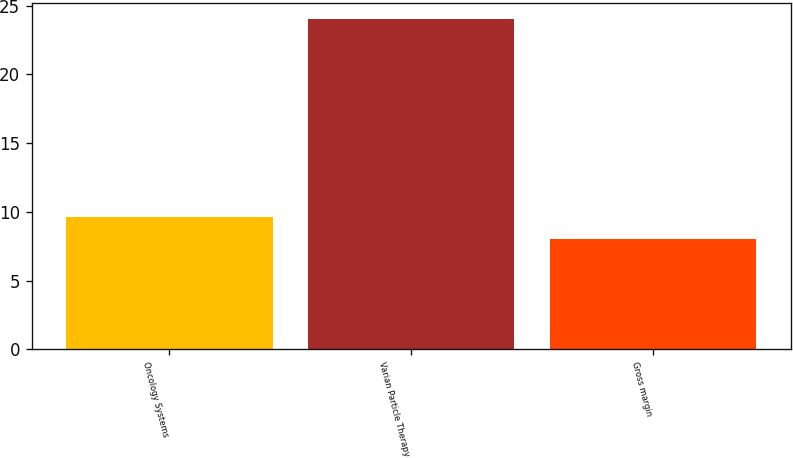<chart> <loc_0><loc_0><loc_500><loc_500><bar_chart><fcel>Oncology Systems<fcel>Varian Particle Therapy<fcel>Gross margin<nl><fcel>9.6<fcel>24<fcel>8<nl></chart> 